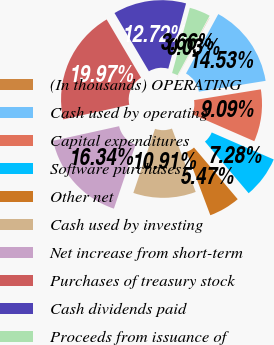<chart> <loc_0><loc_0><loc_500><loc_500><pie_chart><fcel>(In thousands) OPERATING<fcel>Cash used by operating<fcel>Capital expenditures<fcel>Software purchases<fcel>Other net<fcel>Cash used by investing<fcel>Net increase from short-term<fcel>Purchases of treasury stock<fcel>Cash dividends paid<fcel>Proceeds from issuance of<nl><fcel>0.03%<fcel>14.53%<fcel>9.09%<fcel>7.28%<fcel>5.47%<fcel>10.91%<fcel>16.34%<fcel>19.97%<fcel>12.72%<fcel>3.66%<nl></chart> 